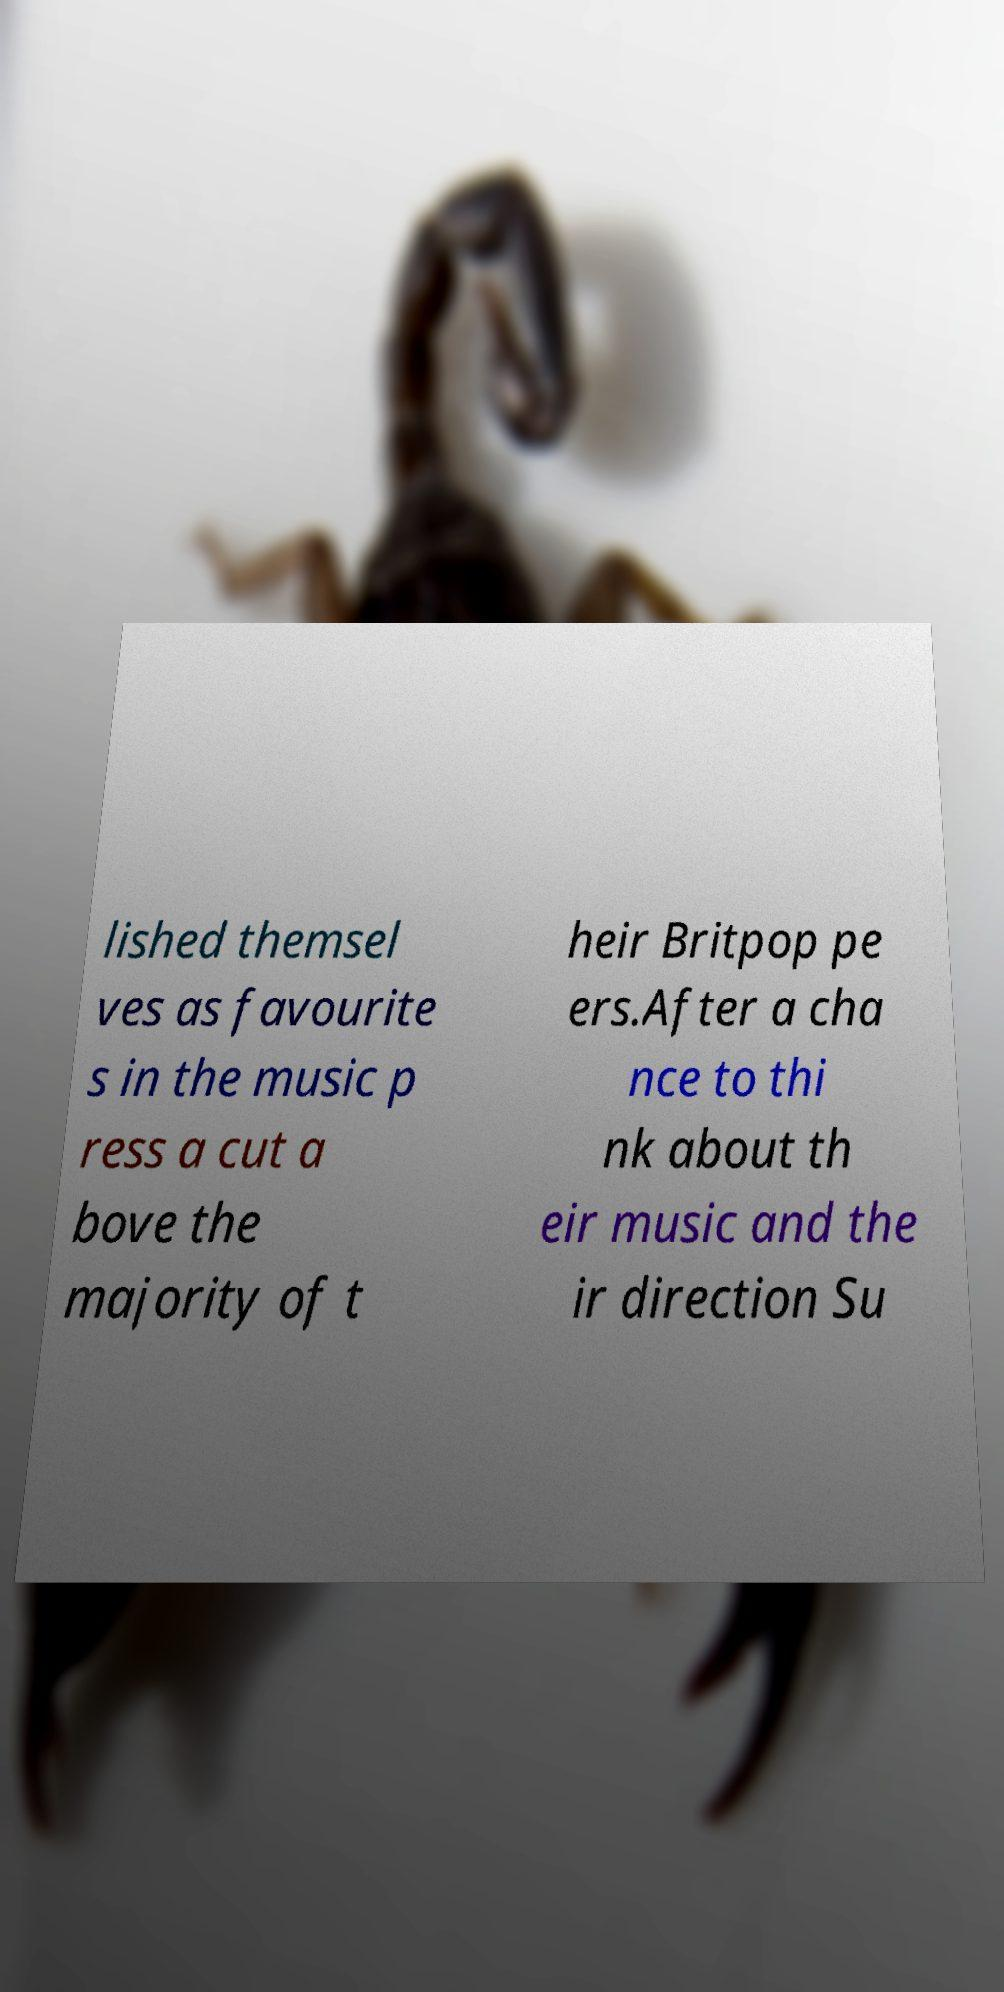Please identify and transcribe the text found in this image. lished themsel ves as favourite s in the music p ress a cut a bove the majority of t heir Britpop pe ers.After a cha nce to thi nk about th eir music and the ir direction Su 